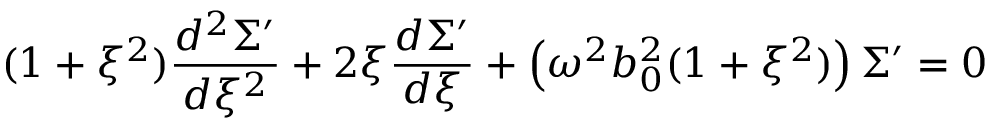<formula> <loc_0><loc_0><loc_500><loc_500>( 1 + \xi ^ { 2 } ) \frac { d ^ { 2 } { \Sigma ^ { \prime } } } { d \xi ^ { 2 } } + 2 \xi \frac { d \Sigma ^ { \prime } } { d \xi } + \left ( \omega ^ { 2 } b _ { 0 } ^ { 2 } ( 1 + \xi ^ { 2 } ) \right ) \Sigma ^ { \prime } = 0</formula> 